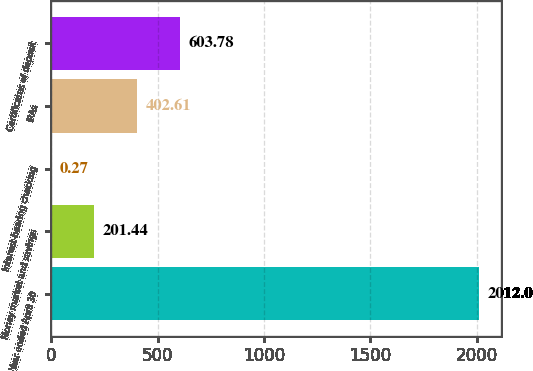Convert chart. <chart><loc_0><loc_0><loc_500><loc_500><bar_chart><fcel>Year ended April 30<fcel>Money market and savings<fcel>Interest-bearing checking<fcel>IRAs<fcel>Certificates of deposit<nl><fcel>2012<fcel>201.44<fcel>0.27<fcel>402.61<fcel>603.78<nl></chart> 